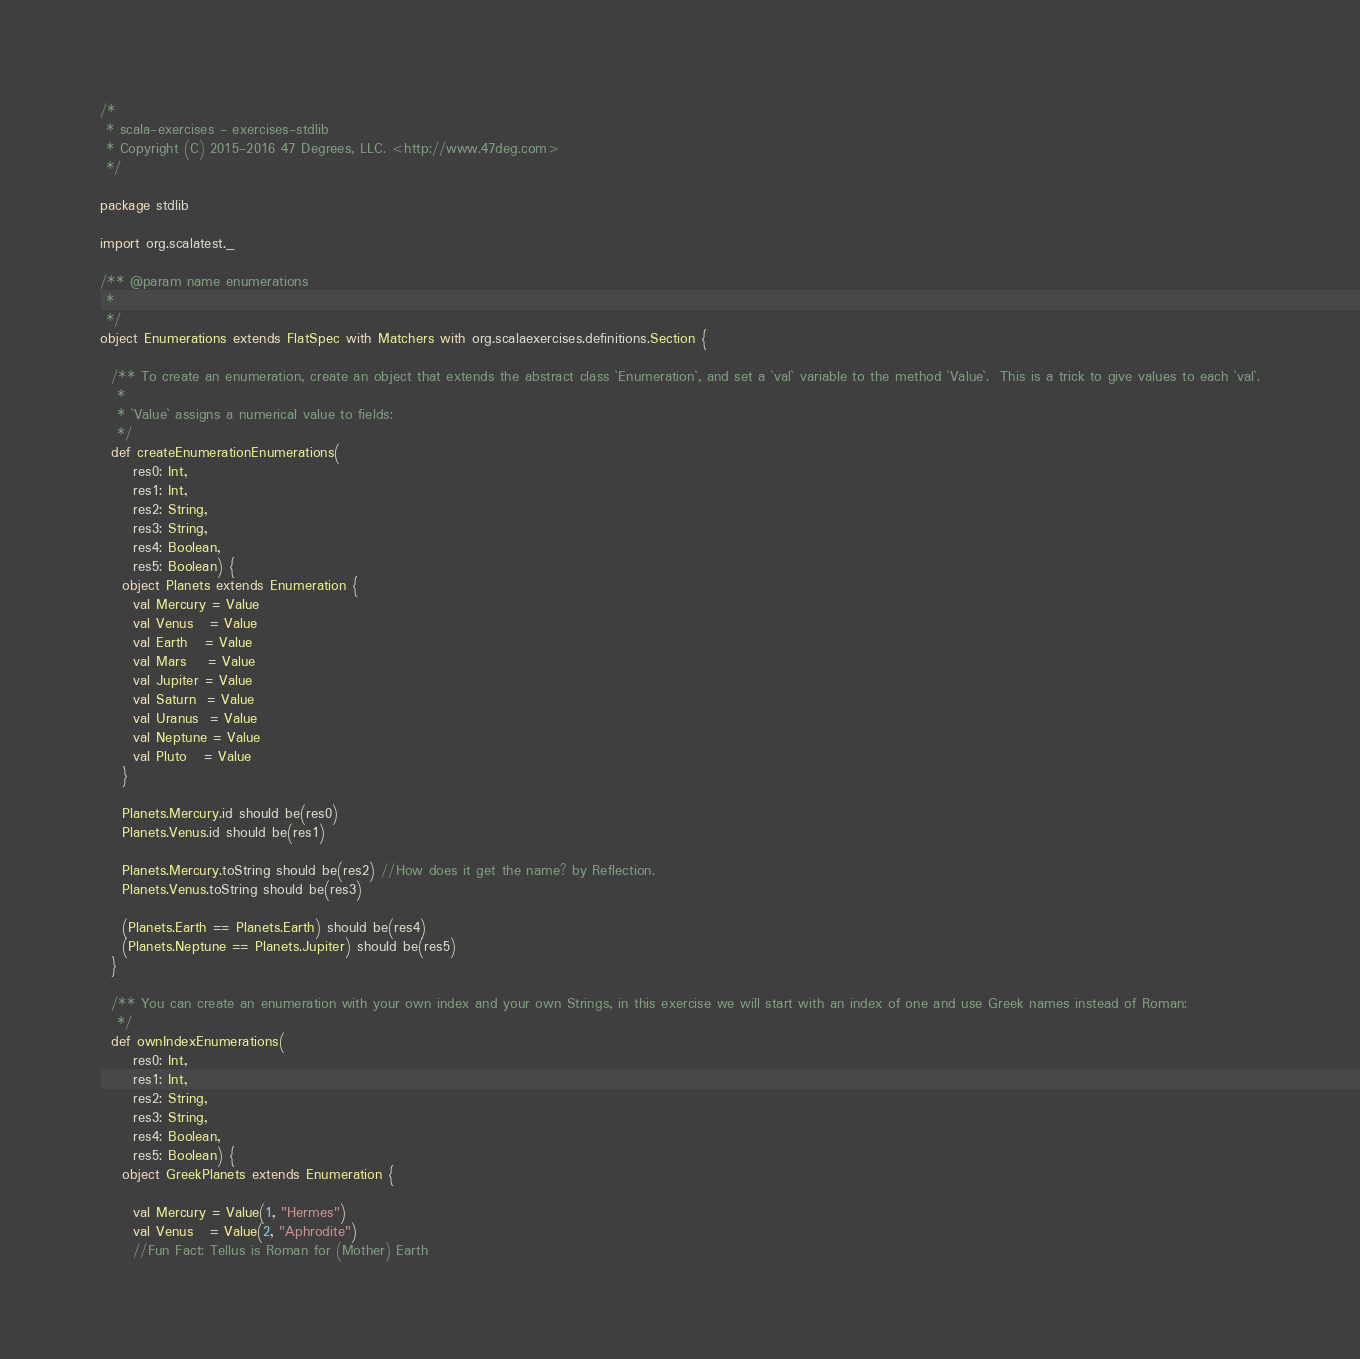Convert code to text. <code><loc_0><loc_0><loc_500><loc_500><_Scala_>/*
 * scala-exercises - exercises-stdlib
 * Copyright (C) 2015-2016 47 Degrees, LLC. <http://www.47deg.com>
 */

package stdlib

import org.scalatest._

/** @param name enumerations
 *
 */
object Enumerations extends FlatSpec with Matchers with org.scalaexercises.definitions.Section {

  /** To create an enumeration, create an object that extends the abstract class `Enumeration`, and set a `val` variable to the method `Value`.  This is a trick to give values to each `val`.
   *
   * `Value` assigns a numerical value to fields:
   */
  def createEnumerationEnumerations(
      res0: Int,
      res1: Int,
      res2: String,
      res3: String,
      res4: Boolean,
      res5: Boolean) {
    object Planets extends Enumeration {
      val Mercury = Value
      val Venus   = Value
      val Earth   = Value
      val Mars    = Value
      val Jupiter = Value
      val Saturn  = Value
      val Uranus  = Value
      val Neptune = Value
      val Pluto   = Value
    }

    Planets.Mercury.id should be(res0)
    Planets.Venus.id should be(res1)

    Planets.Mercury.toString should be(res2) //How does it get the name? by Reflection.
    Planets.Venus.toString should be(res3)

    (Planets.Earth == Planets.Earth) should be(res4)
    (Planets.Neptune == Planets.Jupiter) should be(res5)
  }

  /** You can create an enumeration with your own index and your own Strings, in this exercise we will start with an index of one and use Greek names instead of Roman:
   */
  def ownIndexEnumerations(
      res0: Int,
      res1: Int,
      res2: String,
      res3: String,
      res4: Boolean,
      res5: Boolean) {
    object GreekPlanets extends Enumeration {

      val Mercury = Value(1, "Hermes")
      val Venus   = Value(2, "Aphrodite")
      //Fun Fact: Tellus is Roman for (Mother) Earth</code> 